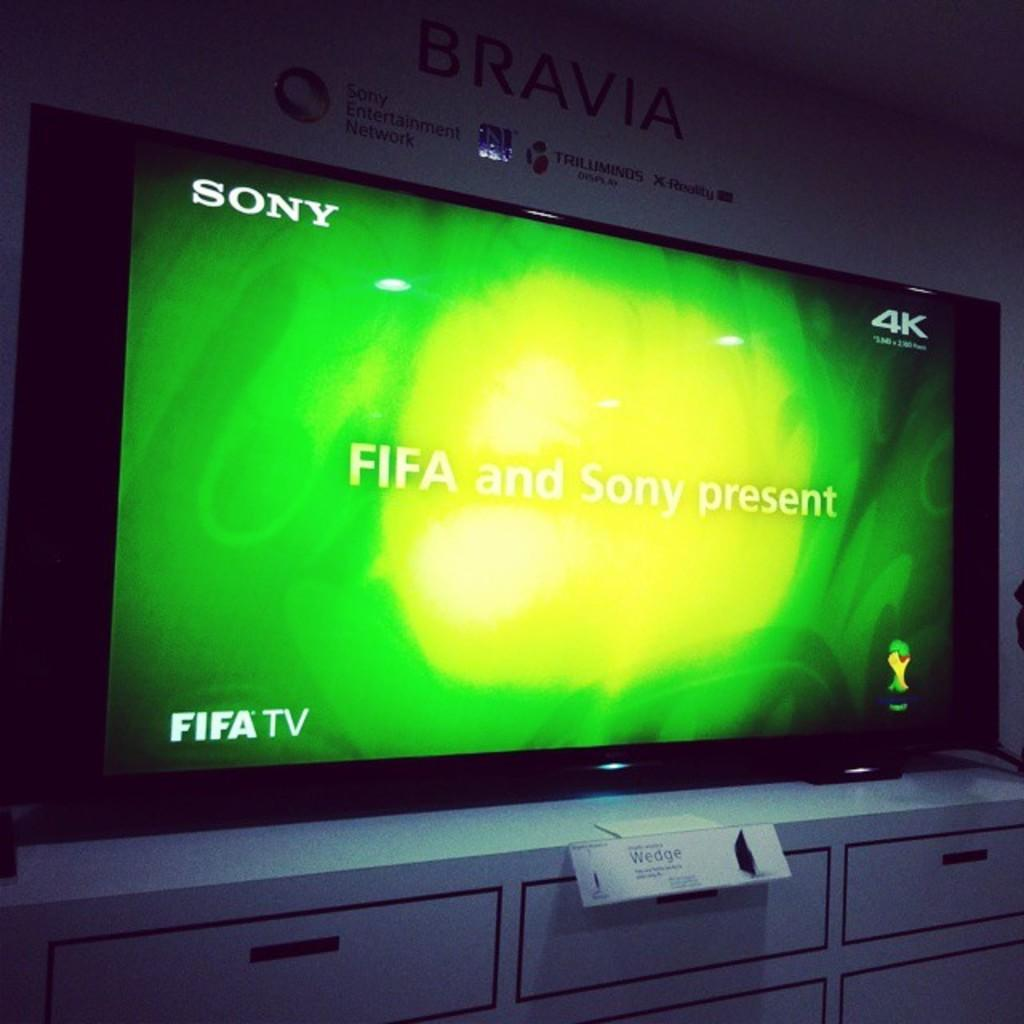<image>
Share a concise interpretation of the image provided. A FIFA and Sony ad on a Sony 4K television. 